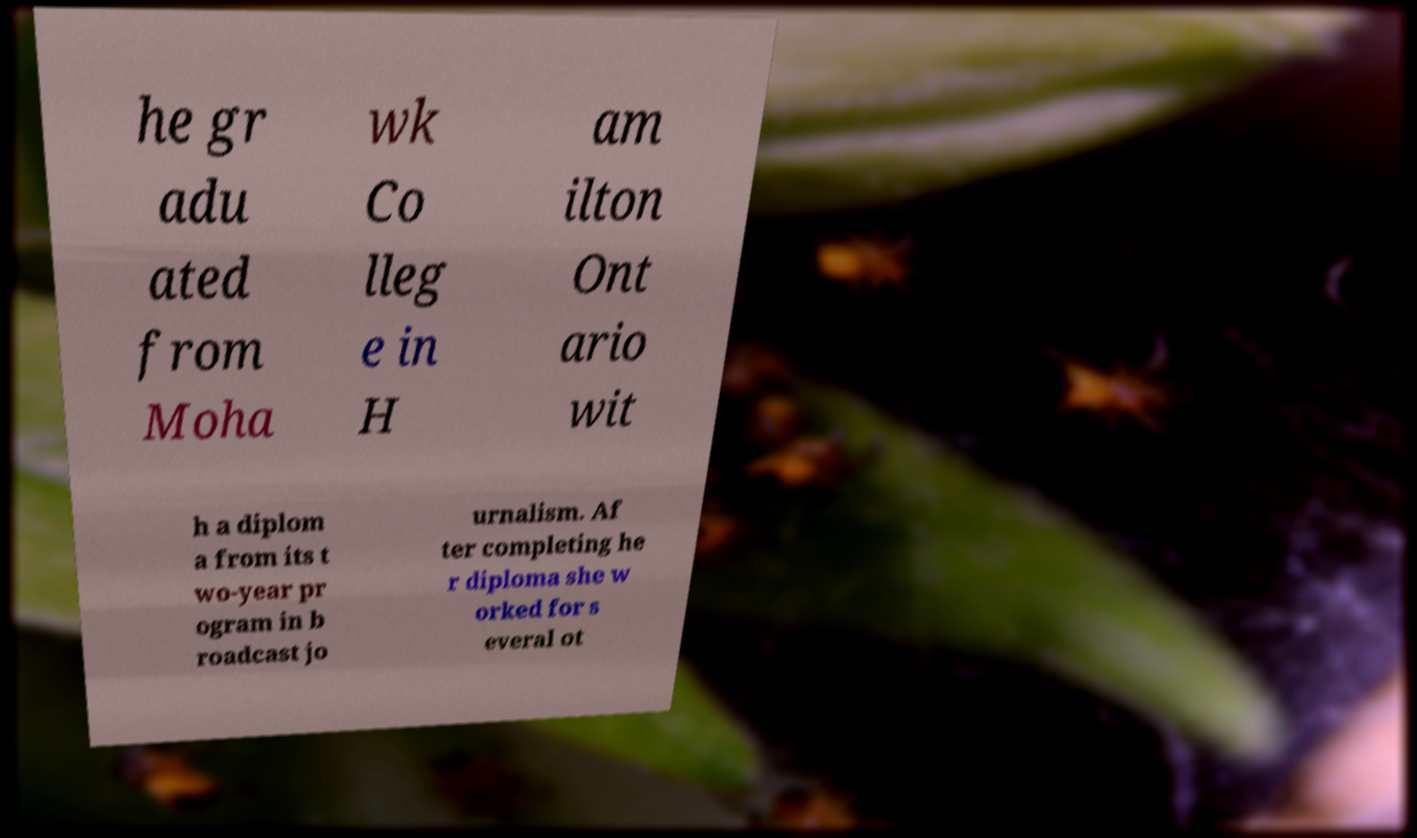Could you assist in decoding the text presented in this image and type it out clearly? he gr adu ated from Moha wk Co lleg e in H am ilton Ont ario wit h a diplom a from its t wo-year pr ogram in b roadcast jo urnalism. Af ter completing he r diploma she w orked for s everal ot 